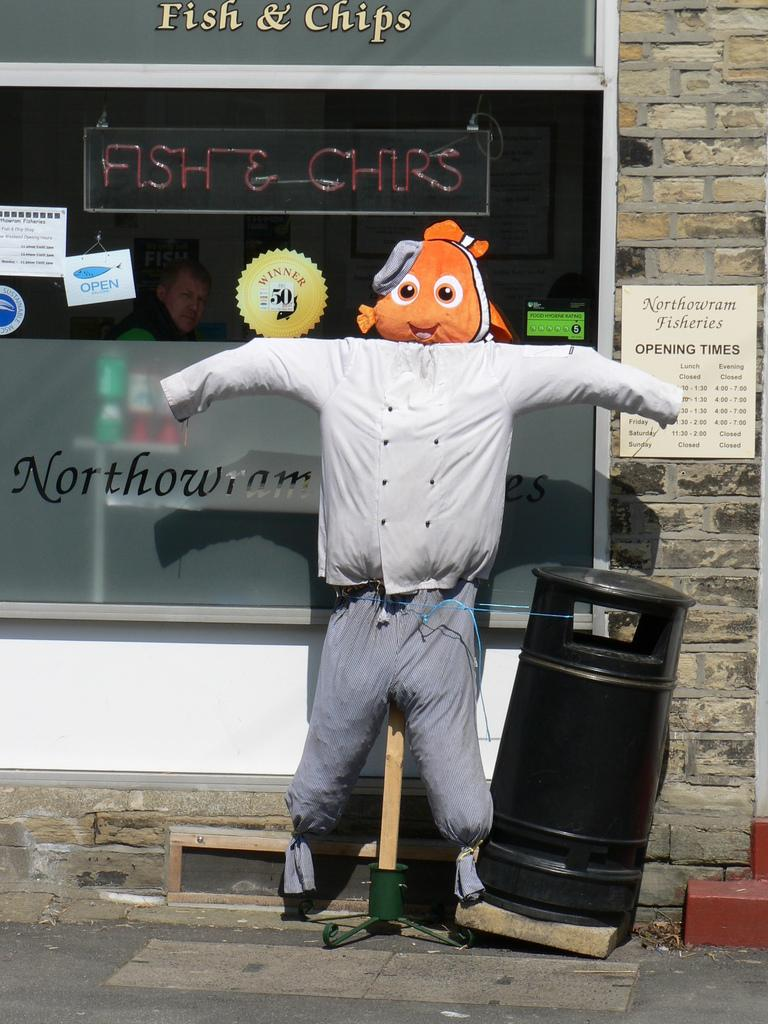<image>
Describe the image concisely. A life-size fish head doll is outside a fish & chips restaurant. 